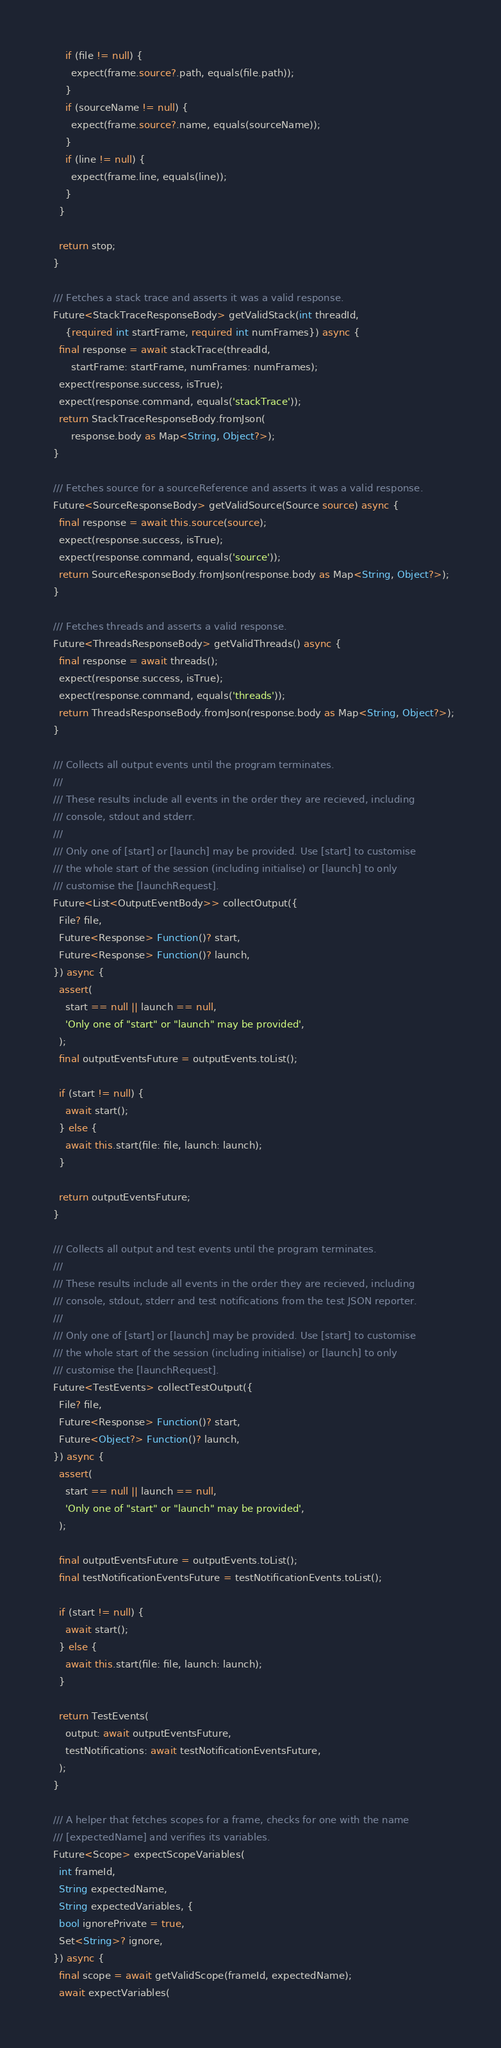Convert code to text. <code><loc_0><loc_0><loc_500><loc_500><_Dart_>      if (file != null) {
        expect(frame.source?.path, equals(file.path));
      }
      if (sourceName != null) {
        expect(frame.source?.name, equals(sourceName));
      }
      if (line != null) {
        expect(frame.line, equals(line));
      }
    }

    return stop;
  }

  /// Fetches a stack trace and asserts it was a valid response.
  Future<StackTraceResponseBody> getValidStack(int threadId,
      {required int startFrame, required int numFrames}) async {
    final response = await stackTrace(threadId,
        startFrame: startFrame, numFrames: numFrames);
    expect(response.success, isTrue);
    expect(response.command, equals('stackTrace'));
    return StackTraceResponseBody.fromJson(
        response.body as Map<String, Object?>);
  }

  /// Fetches source for a sourceReference and asserts it was a valid response.
  Future<SourceResponseBody> getValidSource(Source source) async {
    final response = await this.source(source);
    expect(response.success, isTrue);
    expect(response.command, equals('source'));
    return SourceResponseBody.fromJson(response.body as Map<String, Object?>);
  }

  /// Fetches threads and asserts a valid response.
  Future<ThreadsResponseBody> getValidThreads() async {
    final response = await threads();
    expect(response.success, isTrue);
    expect(response.command, equals('threads'));
    return ThreadsResponseBody.fromJson(response.body as Map<String, Object?>);
  }

  /// Collects all output events until the program terminates.
  ///
  /// These results include all events in the order they are recieved, including
  /// console, stdout and stderr.
  ///
  /// Only one of [start] or [launch] may be provided. Use [start] to customise
  /// the whole start of the session (including initialise) or [launch] to only
  /// customise the [launchRequest].
  Future<List<OutputEventBody>> collectOutput({
    File? file,
    Future<Response> Function()? start,
    Future<Response> Function()? launch,
  }) async {
    assert(
      start == null || launch == null,
      'Only one of "start" or "launch" may be provided',
    );
    final outputEventsFuture = outputEvents.toList();

    if (start != null) {
      await start();
    } else {
      await this.start(file: file, launch: launch);
    }

    return outputEventsFuture;
  }

  /// Collects all output and test events until the program terminates.
  ///
  /// These results include all events in the order they are recieved, including
  /// console, stdout, stderr and test notifications from the test JSON reporter.
  ///
  /// Only one of [start] or [launch] may be provided. Use [start] to customise
  /// the whole start of the session (including initialise) or [launch] to only
  /// customise the [launchRequest].
  Future<TestEvents> collectTestOutput({
    File? file,
    Future<Response> Function()? start,
    Future<Object?> Function()? launch,
  }) async {
    assert(
      start == null || launch == null,
      'Only one of "start" or "launch" may be provided',
    );

    final outputEventsFuture = outputEvents.toList();
    final testNotificationEventsFuture = testNotificationEvents.toList();

    if (start != null) {
      await start();
    } else {
      await this.start(file: file, launch: launch);
    }

    return TestEvents(
      output: await outputEventsFuture,
      testNotifications: await testNotificationEventsFuture,
    );
  }

  /// A helper that fetches scopes for a frame, checks for one with the name
  /// [expectedName] and verifies its variables.
  Future<Scope> expectScopeVariables(
    int frameId,
    String expectedName,
    String expectedVariables, {
    bool ignorePrivate = true,
    Set<String>? ignore,
  }) async {
    final scope = await getValidScope(frameId, expectedName);
    await expectVariables(</code> 